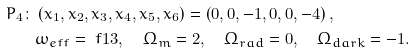<formula> <loc_0><loc_0><loc_500><loc_500>P _ { 4 } \colon & \left ( x _ { 1 } , x _ { 2 } , x _ { 3 } , x _ { 4 } , x _ { 5 } , x _ { 6 } \right ) = \left ( 0 , 0 , - 1 , 0 , 0 , - 4 \right ) , \\ & \omega _ { e f f } = \ f { 1 } { 3 } , \quad \Omega _ { m } = 2 , \quad \Omega _ { r a d } = 0 , \quad \Omega _ { d a r k } = - 1 .</formula> 